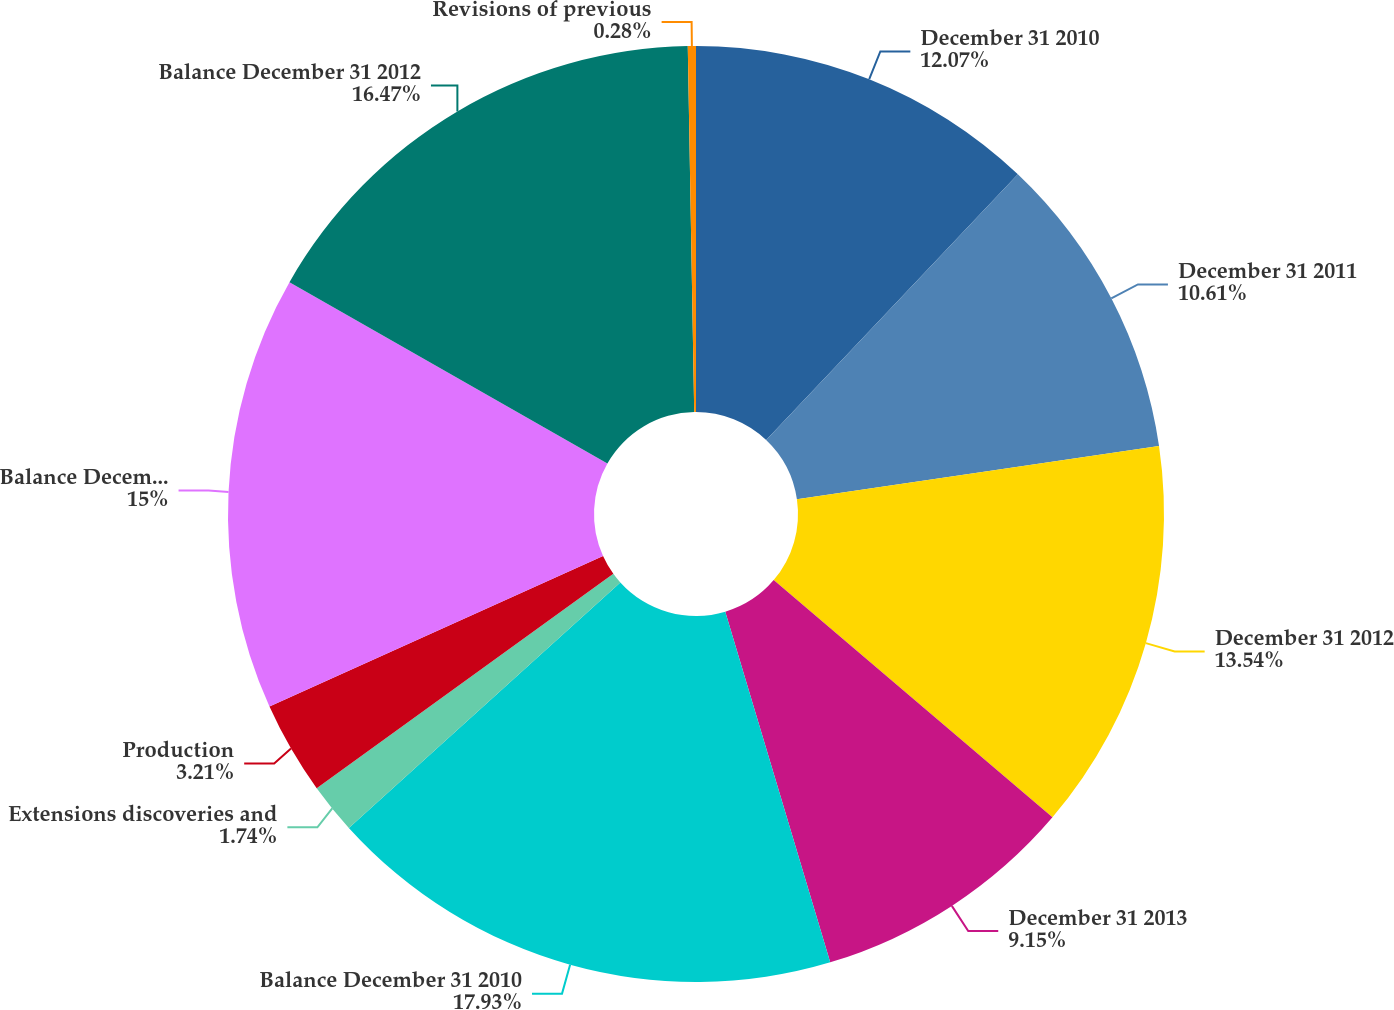Convert chart to OTSL. <chart><loc_0><loc_0><loc_500><loc_500><pie_chart><fcel>December 31 2010<fcel>December 31 2011<fcel>December 31 2012<fcel>December 31 2013<fcel>Balance December 31 2010<fcel>Extensions discoveries and<fcel>Production<fcel>Balance December 31 2011<fcel>Balance December 31 2012<fcel>Revisions of previous<nl><fcel>12.07%<fcel>10.61%<fcel>13.54%<fcel>9.15%<fcel>17.93%<fcel>1.74%<fcel>3.21%<fcel>15.0%<fcel>16.47%<fcel>0.28%<nl></chart> 